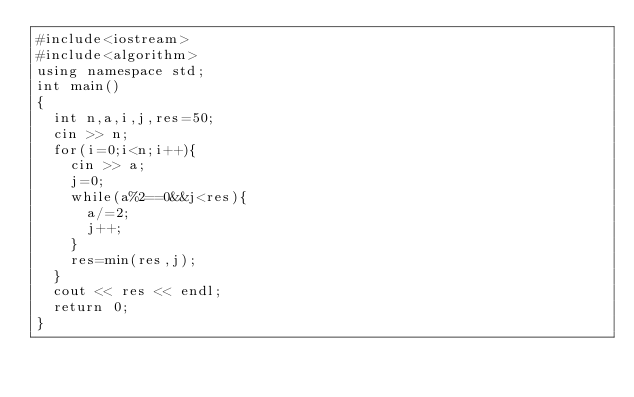Convert code to text. <code><loc_0><loc_0><loc_500><loc_500><_C++_>#include<iostream>
#include<algorithm>
using namespace std;
int main()
{
  int n,a,i,j,res=50;
  cin >> n;
  for(i=0;i<n;i++){
    cin >> a;
    j=0;
    while(a%2==0&&j<res){
      a/=2;
      j++;
    }
    res=min(res,j);
  }
  cout << res << endl;
  return 0;
}</code> 